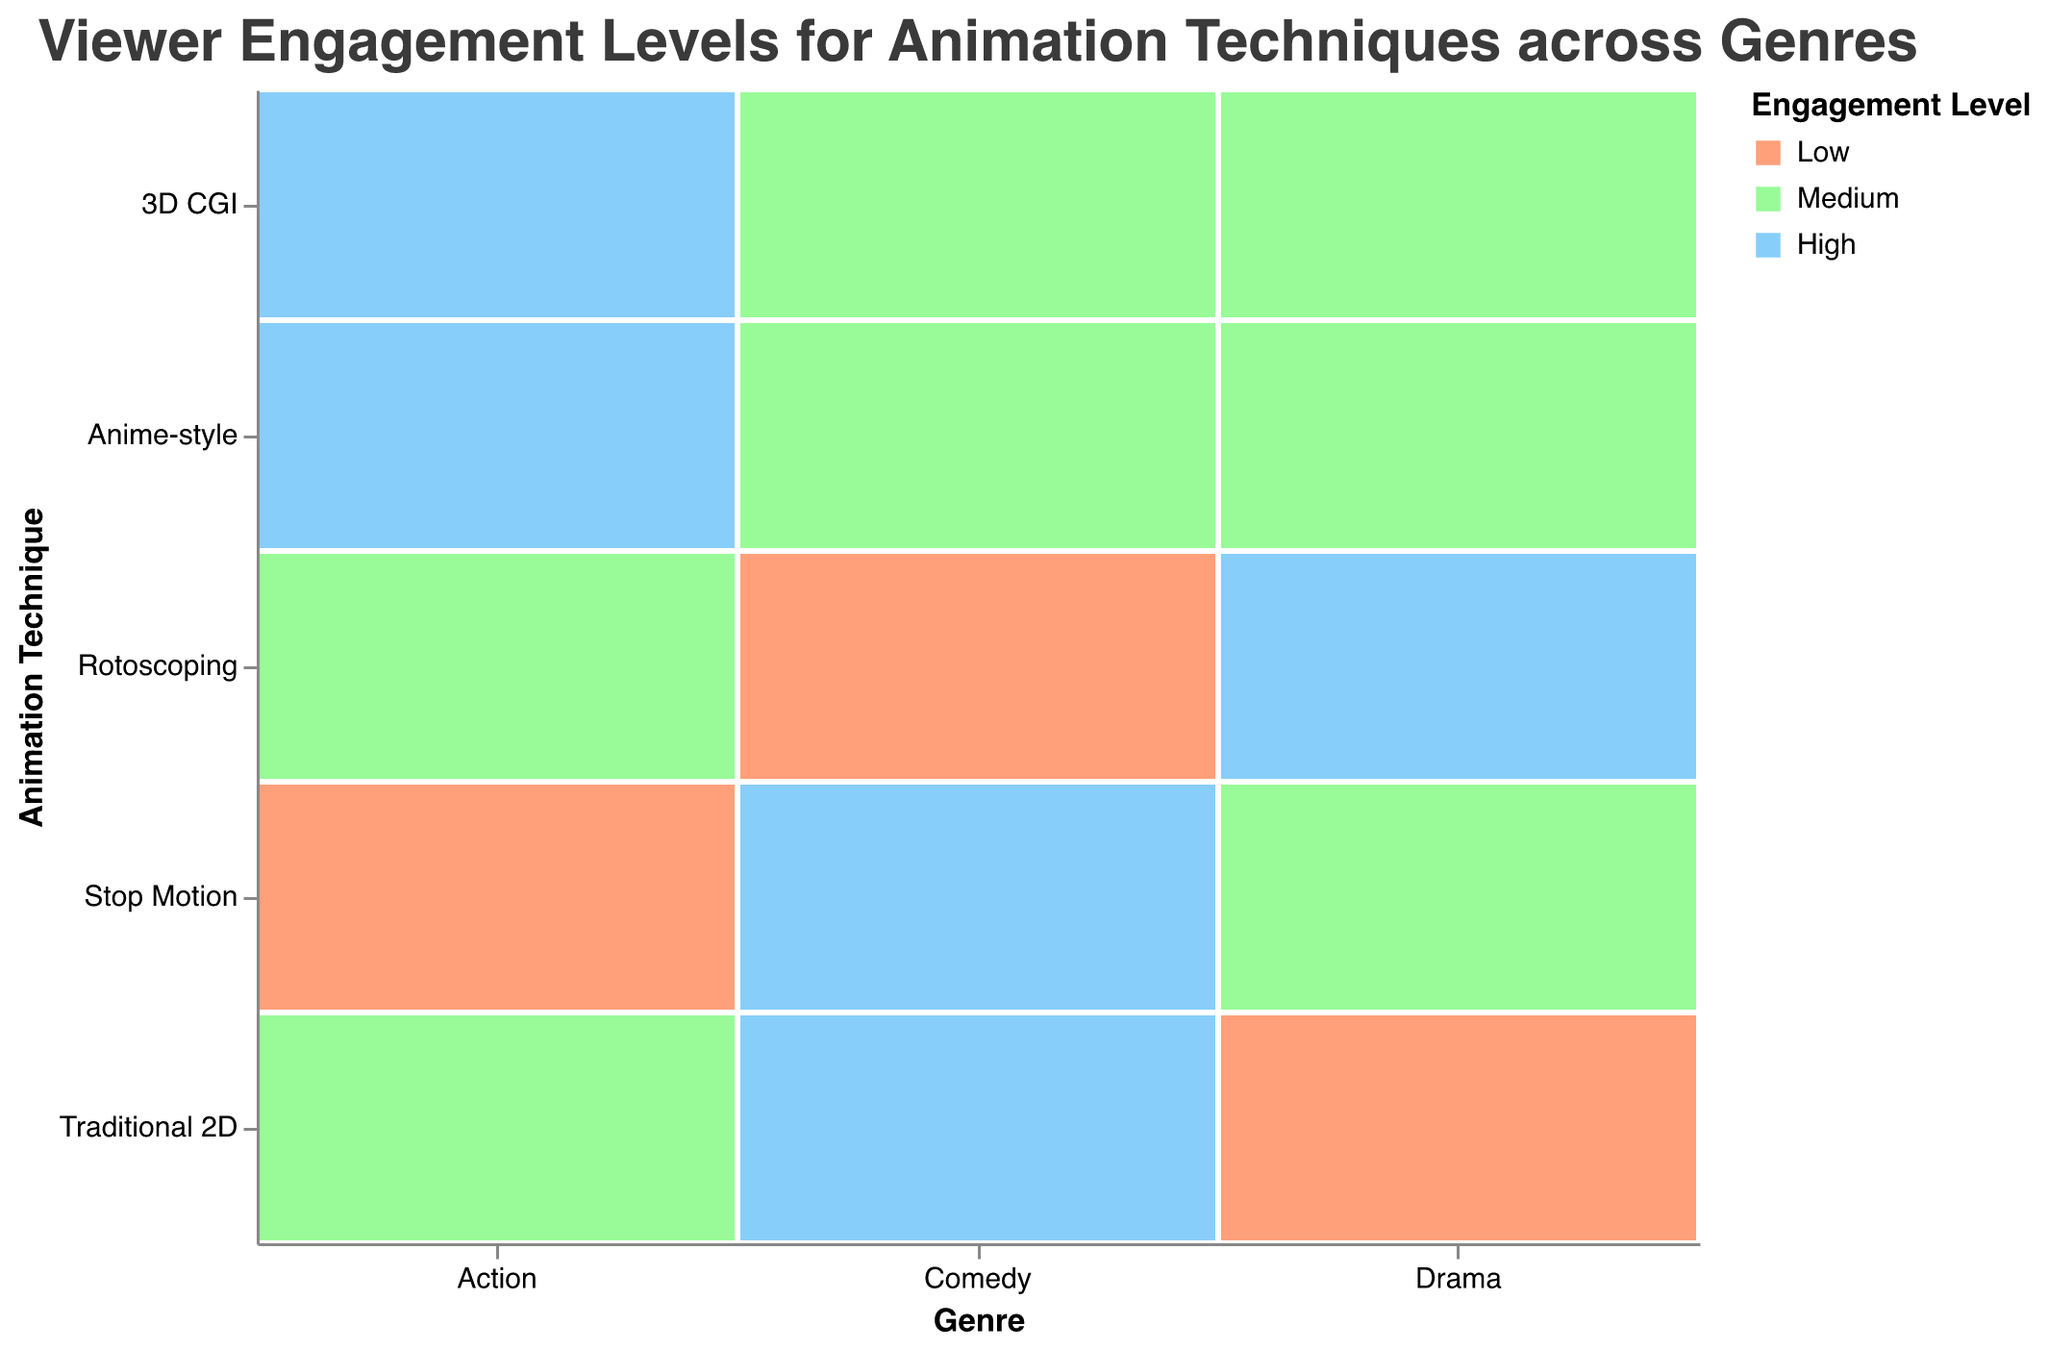What is the engagement level for Traditional 2D Comedy? The intersection of Traditional 2D and Comedy is highlighted with a color representing High engagement.
Answer: High What genre has the highest engagement level for 3D CGI? The intersections of 3D CGI with different genres show that Action has High engagement while Comedy and Drama have Medium engagement.
Answer: Action Which animation technique shows Medium engagement in Drama? At the intersection of Drama with different techniques, 3D CGI, Stop Motion, and Anime-style all have Medium engagement.
Answer: 3D CGI, Stop Motion, Anime-style How does Rotoscoping compare to other animation techniques in Comedy? In the Comedy genre, Rotoscoping shows Low engagement, while Traditional 2D and Stop Motion have High engagement, 3D CGI and Anime-style have Medium engagement.
Answer: Lower engagement What's the most common engagement level across all the animation techniques and genres? By counting the occurrences of each engagement level, Medium appears the most frequently.
Answer: Medium 